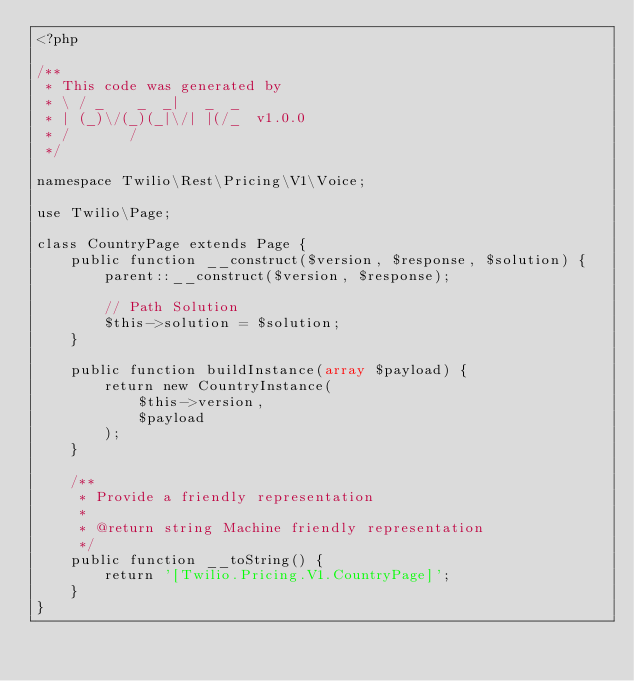Convert code to text. <code><loc_0><loc_0><loc_500><loc_500><_PHP_><?php

/**
 * This code was generated by
 * \ / _    _  _|   _  _
 * | (_)\/(_)(_|\/| |(/_  v1.0.0
 * /       /
 */

namespace Twilio\Rest\Pricing\V1\Voice;

use Twilio\Page;

class CountryPage extends Page {
    public function __construct($version, $response, $solution) {
        parent::__construct($version, $response);
        
        // Path Solution
        $this->solution = $solution;
    }

    public function buildInstance(array $payload) {
        return new CountryInstance(
            $this->version,
            $payload
        );
    }

    /**
     * Provide a friendly representation
     * 
     * @return string Machine friendly representation
     */
    public function __toString() {
        return '[Twilio.Pricing.V1.CountryPage]';
    }
}</code> 